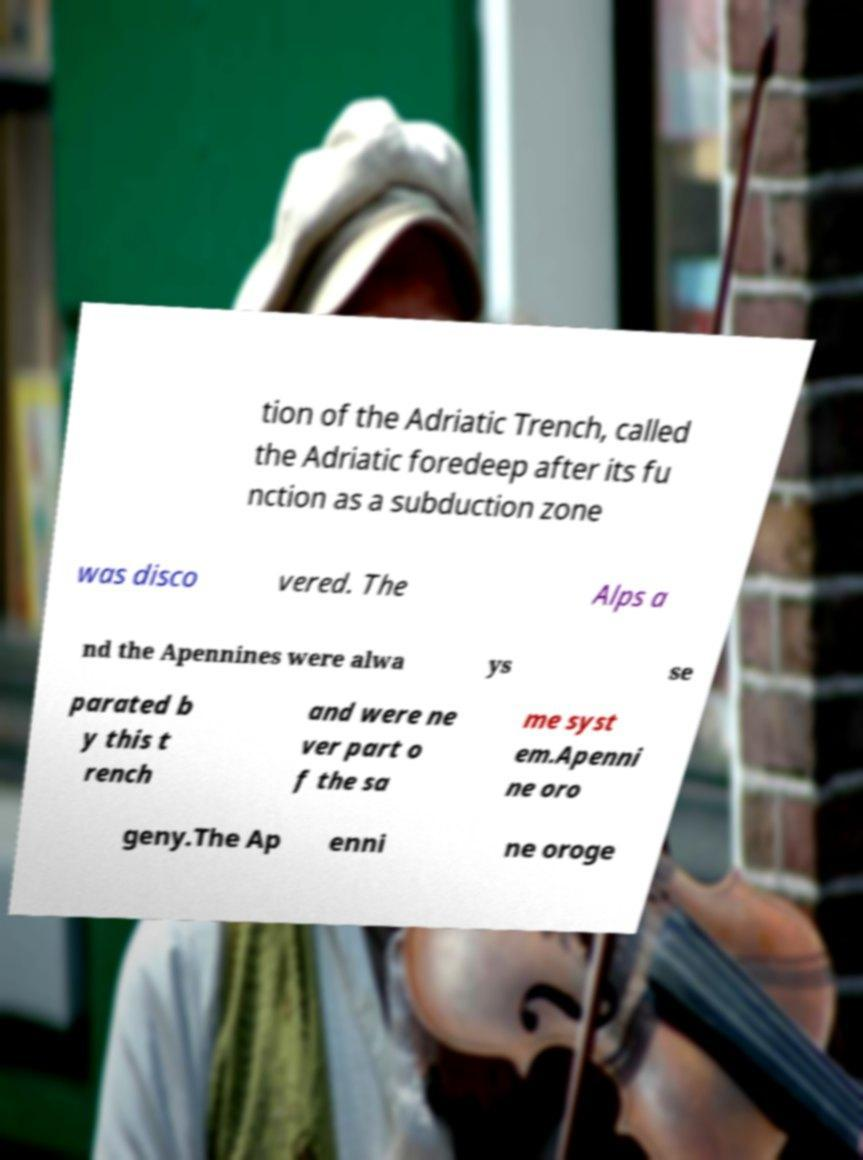For documentation purposes, I need the text within this image transcribed. Could you provide that? tion of the Adriatic Trench, called the Adriatic foredeep after its fu nction as a subduction zone was disco vered. The Alps a nd the Apennines were alwa ys se parated b y this t rench and were ne ver part o f the sa me syst em.Apenni ne oro geny.The Ap enni ne oroge 